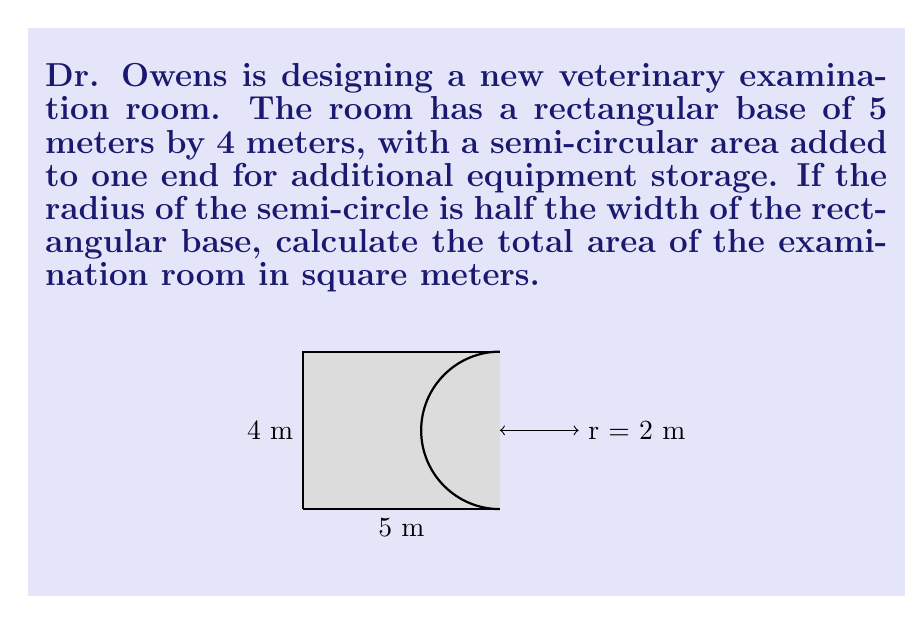Provide a solution to this math problem. To solve this problem, we'll break it down into steps:

1) First, calculate the area of the rectangular base:
   $$A_{rectangle} = length \times width = 5 \text{ m} \times 4 \text{ m} = 20 \text{ m}^2$$

2) Next, determine the radius of the semi-circle:
   The radius is half the width of the rectangular base.
   $$r = \frac{4 \text{ m}}{2} = 2 \text{ m}$$

3) Calculate the area of the full circle:
   $$A_{circle} = \pi r^2 = \pi \times (2 \text{ m})^2 = 4\pi \text{ m}^2$$

4) Since we only need half of the circle, divide this area by 2:
   $$A_{semi-circle} = \frac{4\pi \text{ m}^2}{2} = 2\pi \text{ m}^2$$

5) The total area is the sum of the rectangular area and the semi-circular area:
   $$A_{total} = A_{rectangle} + A_{semi-circle} = 20 \text{ m}^2 + 2\pi \text{ m}^2$$

6) Simplify:
   $$A_{total} = (20 + 2\pi) \text{ m}^2 \approx 26.28 \text{ m}^2$$
Answer: $(20 + 2\pi) \text{ m}^2$ or approximately $26.28 \text{ m}^2$ 